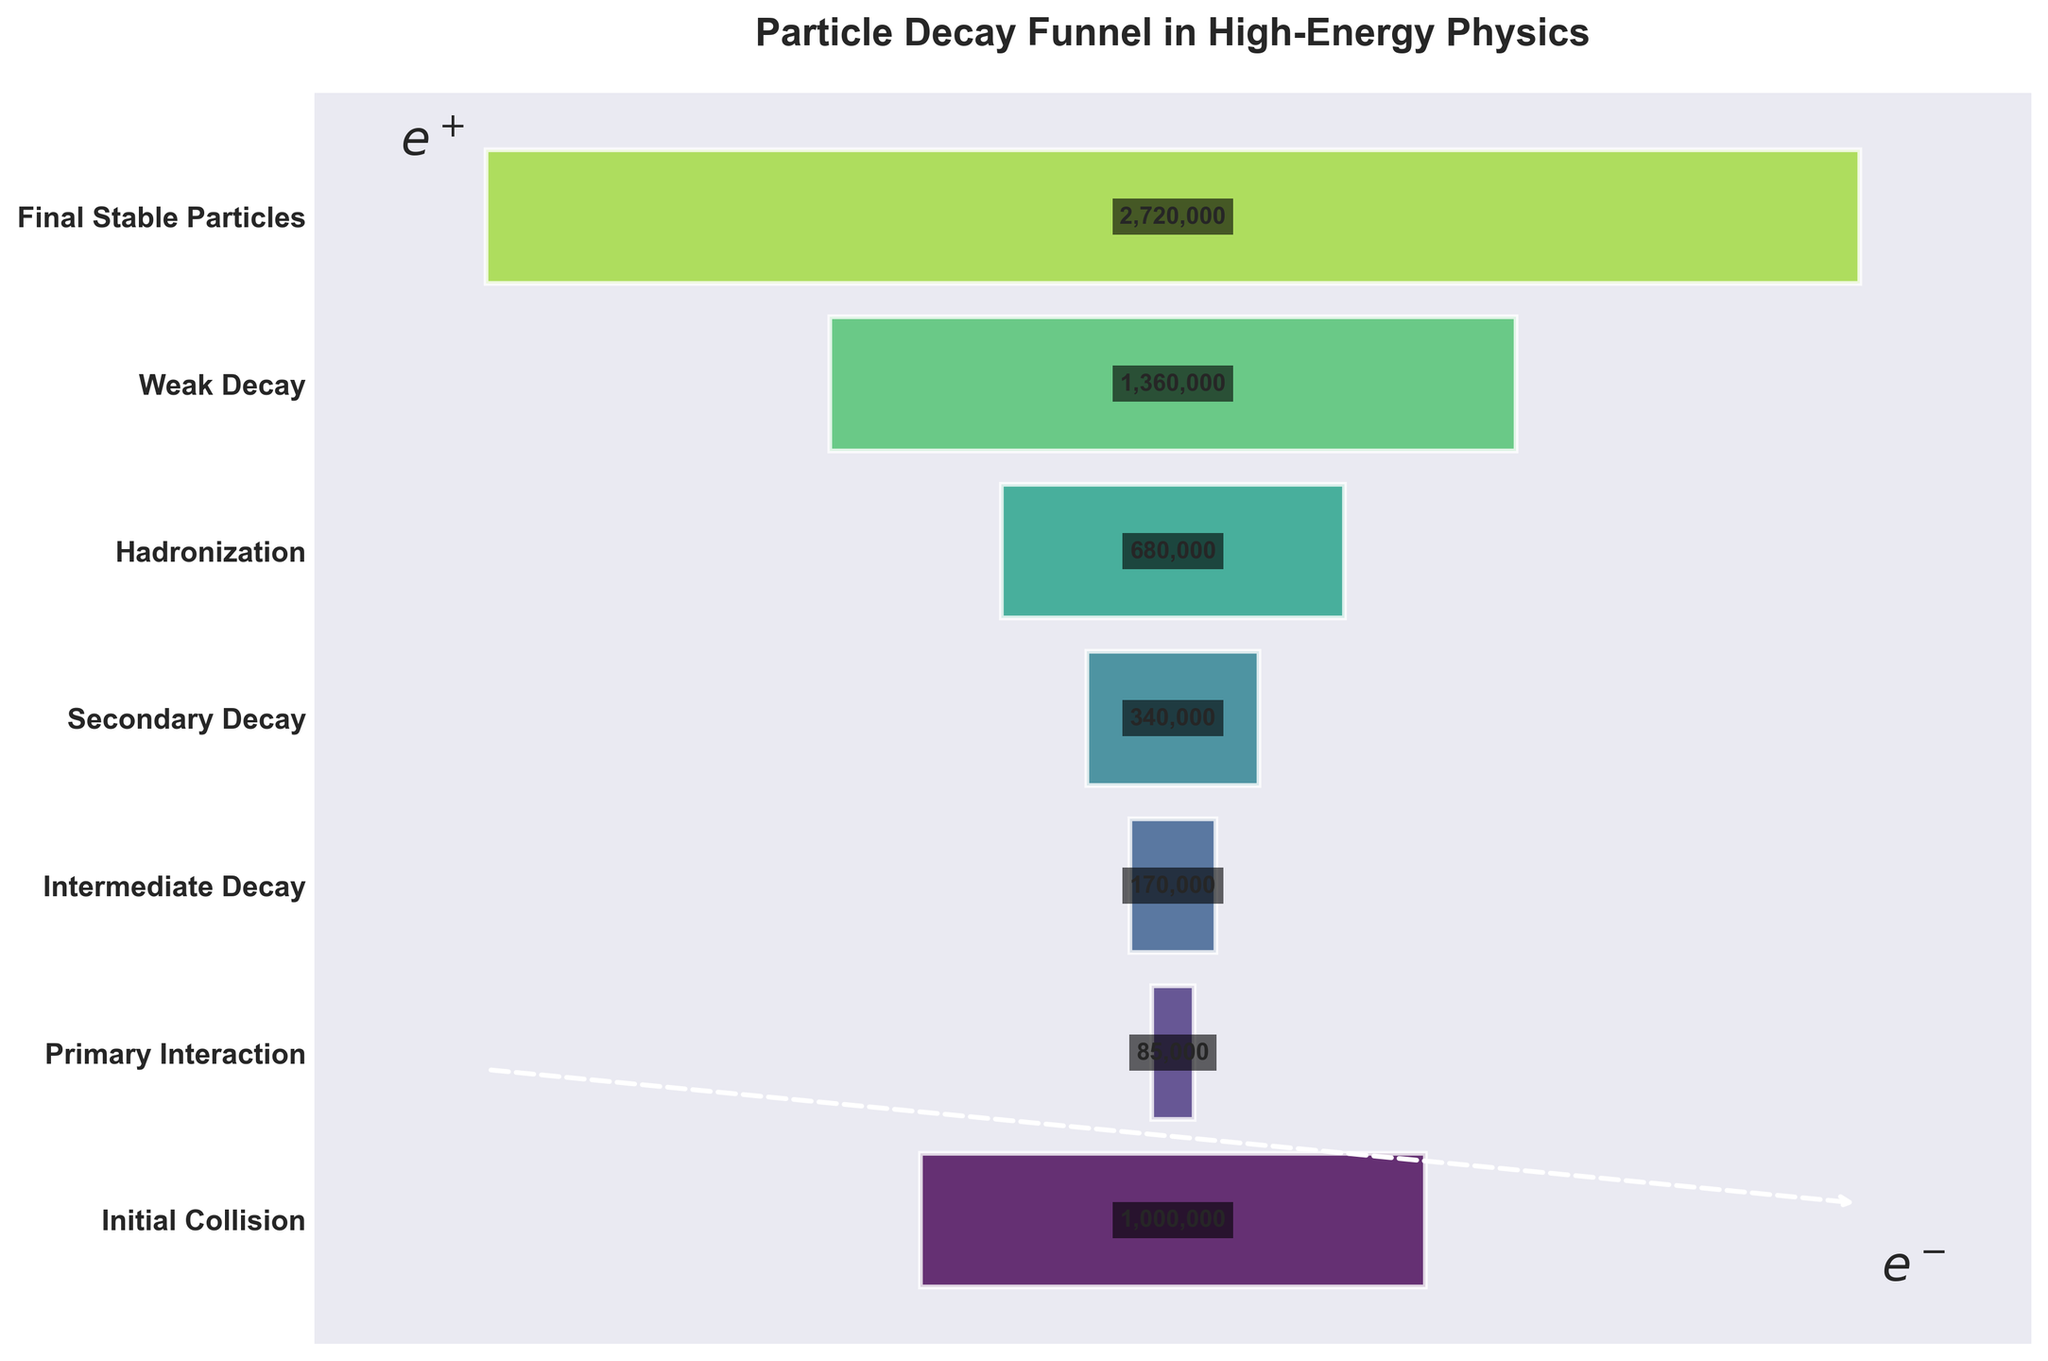what is the title of the figure? The title can be found at the top of the figure and it usually describes the main focus. In this case, it's "Particle Decay Funnel in High-Energy Physics."
Answer: Particle Decay Funnel in High-Energy Physics How many stages of particle decay are shown in the figure? Counting the number of distinct stages labeled along the y-axis gives us the answer. There are seven stages: Initial Collision, Primary Interaction, Intermediate Decay, Secondary Decay, Hadronization, Weak Decay, and Final Stable Particles.
Answer: Seven Which stage has the highest count of particles? By observing the bar lengths, we see that the "Final Stable Particles" stage has the highest count of 2,720,000 particles.
Answer: Final Stable Particles How does the count of particles in the "Primary Interaction" stage compare to the "Intermediate Decay" stage? The "Primary Interaction" stage has 85,000 particles, whereas the "Intermediate Decay" stage has 170,000 particles. By comparing, the Intermediate Decay stage has twice as many particles as the Primary Interaction stage.
Answer: Intermediate Decay has twice as many particles as Primary Interaction Calculate the total number of particles from the "Secondary Decay" to the "Final Stable Particles" stage. The counts are given as 340,000 (Secondary Decay), 680,000 (Hadronization), 1,360,000 (Weak Decay), and 2,720,000 (Final Stable Particles). Sum: 340,000 + 680,000 + 1,360,000 + 2,720,000 = 5,100,000 particles.
Answer: 5,100,000 particles What is the ratio of particle counts between "Weak Decay" and "Initial Collision"? We have 1,360,000 particles in Weak Decay and 1,000,000 in Initial Collision. The ratio is 1,360,000/1,000,000 = 1.36.
Answer: 1.36 Is the number of particles in the "Hadronization" stage greater than the combined particles in the "Primary Interaction" and "Intermediate Decay" stages? "Hadronization" has 680,000 particles. "Primary Interaction" has 85,000 and "Intermediate Decay" has 170,000. Summing Primary Interaction and Intermediate Decay gives 85,000 + 170,000 = 255,000, which is less than 680,000.
Answer: Yes How many particles decay at each step on average? Summing the counts: 1,000,000 + 85,000 + 170,000 + 340,000 + 680,000 + 1,360,000 + 2,720,000 = 6,355,000 particles. Dividing by 7 stages gives an average of 6,355,000 / 7 ≈ 907,857 particles per stage.
Answer: About 907,857 particles per stage Which stage witnesses the most significant jump in the particle count? Subtract consecutive stages’ counts: 
1. Primary to Intermediate: 170,000 - 85,000 = 85,000
2. Intermediate to Secondary: 340,000 - 170,000 = 170,000
3. Secondary to Hadronization: 680,000 - 340,000 = 340,000
4. Hadronization to Weak: 1,360,000 - 680,000 = 680,000
5. Weak to Final Stable: 2,720,000 - 1,360,000 = 1,360,000. 
The most significant jump is from Weak Decay to Final Stable Particles.
Answer: Weak Decay to Final Stable Particles What can be inferred from the size of the arrow annotated on the figure? The arrow, styled like a Feynman diagram, might indicate the interaction between an electron and a positron, leading to their annihilation or other interactions relevant to particle decay, visually emphasizing the quantum processes involved.
Answer: Indication of fundamental particle interactions 